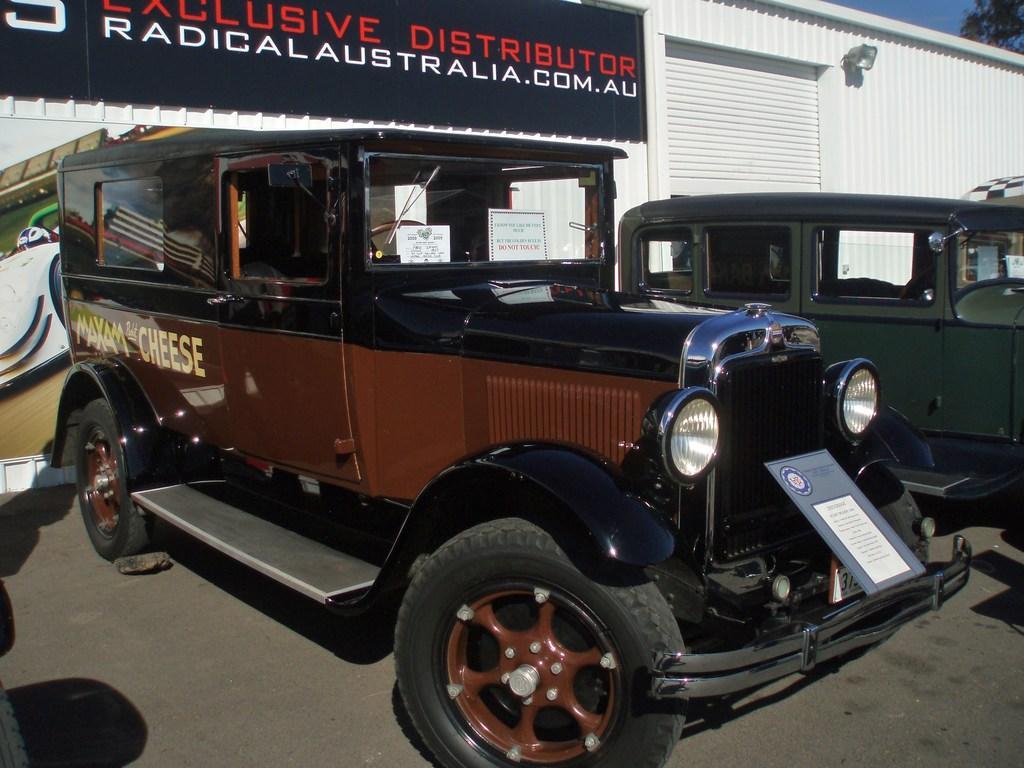Can you describe this image briefly? In the picture I can see few vehicles are on the road, behind we can see board to the shed. 